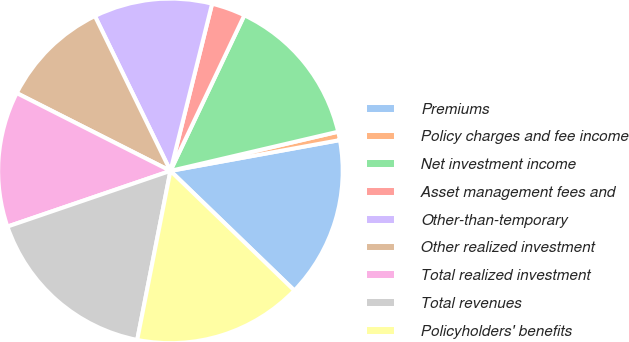<chart> <loc_0><loc_0><loc_500><loc_500><pie_chart><fcel>Premiums<fcel>Policy charges and fee income<fcel>Net investment income<fcel>Asset management fees and<fcel>Other-than-temporary<fcel>Other realized investment<fcel>Total realized investment<fcel>Total revenues<fcel>Policyholders' benefits<nl><fcel>15.08%<fcel>0.79%<fcel>14.29%<fcel>3.17%<fcel>11.11%<fcel>10.32%<fcel>12.7%<fcel>16.67%<fcel>15.87%<nl></chart> 